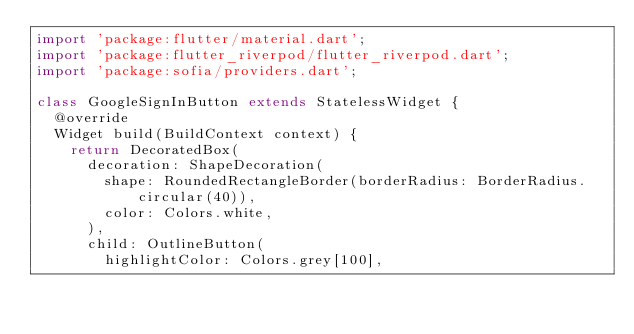<code> <loc_0><loc_0><loc_500><loc_500><_Dart_>import 'package:flutter/material.dart';
import 'package:flutter_riverpod/flutter_riverpod.dart';
import 'package:sofia/providers.dart';

class GoogleSignInButton extends StatelessWidget {
  @override
  Widget build(BuildContext context) {
    return DecoratedBox(
      decoration: ShapeDecoration(
        shape: RoundedRectangleBorder(borderRadius: BorderRadius.circular(40)),
        color: Colors.white,
      ),
      child: OutlineButton(
        highlightColor: Colors.grey[100],</code> 